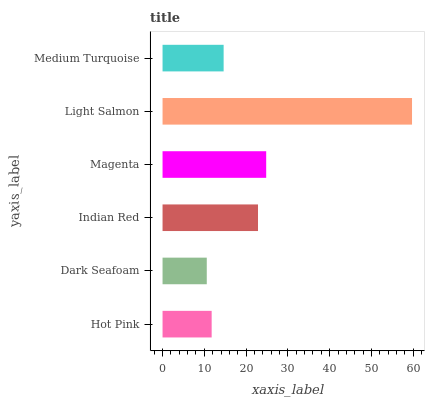Is Dark Seafoam the minimum?
Answer yes or no. Yes. Is Light Salmon the maximum?
Answer yes or no. Yes. Is Indian Red the minimum?
Answer yes or no. No. Is Indian Red the maximum?
Answer yes or no. No. Is Indian Red greater than Dark Seafoam?
Answer yes or no. Yes. Is Dark Seafoam less than Indian Red?
Answer yes or no. Yes. Is Dark Seafoam greater than Indian Red?
Answer yes or no. No. Is Indian Red less than Dark Seafoam?
Answer yes or no. No. Is Indian Red the high median?
Answer yes or no. Yes. Is Medium Turquoise the low median?
Answer yes or no. Yes. Is Light Salmon the high median?
Answer yes or no. No. Is Indian Red the low median?
Answer yes or no. No. 